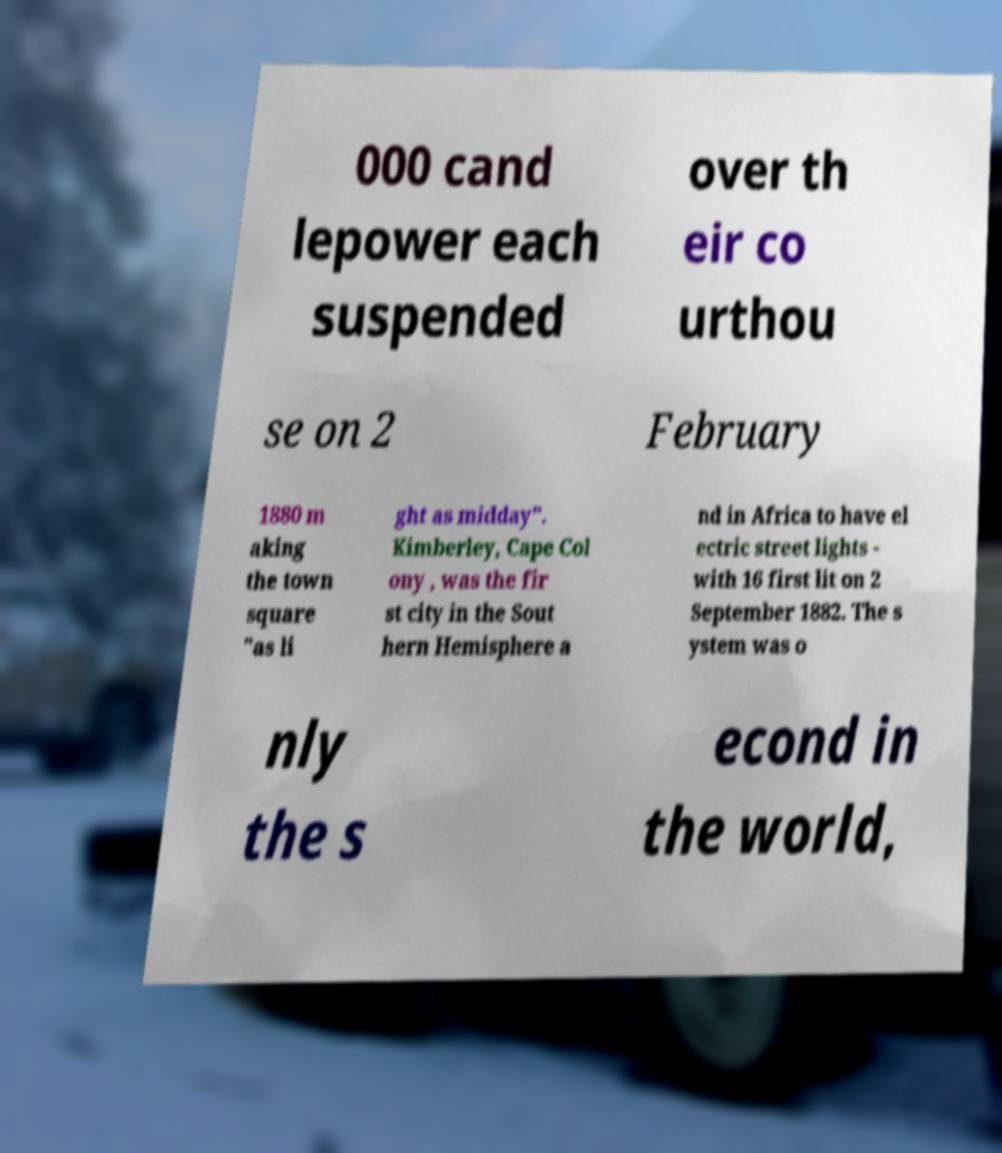Please read and relay the text visible in this image. What does it say? 000 cand lepower each suspended over th eir co urthou se on 2 February 1880 m aking the town square "as li ght as midday". Kimberley, Cape Col ony , was the fir st city in the Sout hern Hemisphere a nd in Africa to have el ectric street lights - with 16 first lit on 2 September 1882. The s ystem was o nly the s econd in the world, 